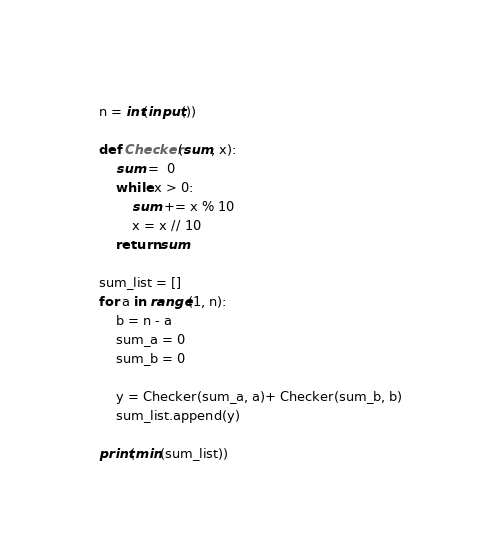Convert code to text. <code><loc_0><loc_0><loc_500><loc_500><_Python_>n = int(input())

def Checker(sum, x):
    sum =  0
    while x > 0:
        sum += x % 10
        x = x // 10
    return sum

sum_list = []
for a in range(1, n):
    b = n - a
    sum_a = 0
    sum_b = 0
    
    y = Checker(sum_a, a)+ Checker(sum_b, b)
    sum_list.append(y)

print(min(sum_list))</code> 